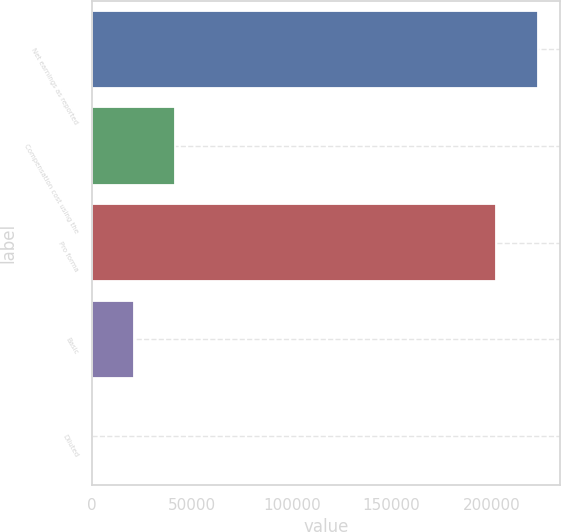Convert chart to OTSL. <chart><loc_0><loc_0><loc_500><loc_500><bar_chart><fcel>Net earnings as reported<fcel>Compensation cost using the<fcel>Pro forma<fcel>Basic<fcel>Diluted<nl><fcel>223277<fcel>41463.2<fcel>202546<fcel>20732.2<fcel>1.28<nl></chart> 